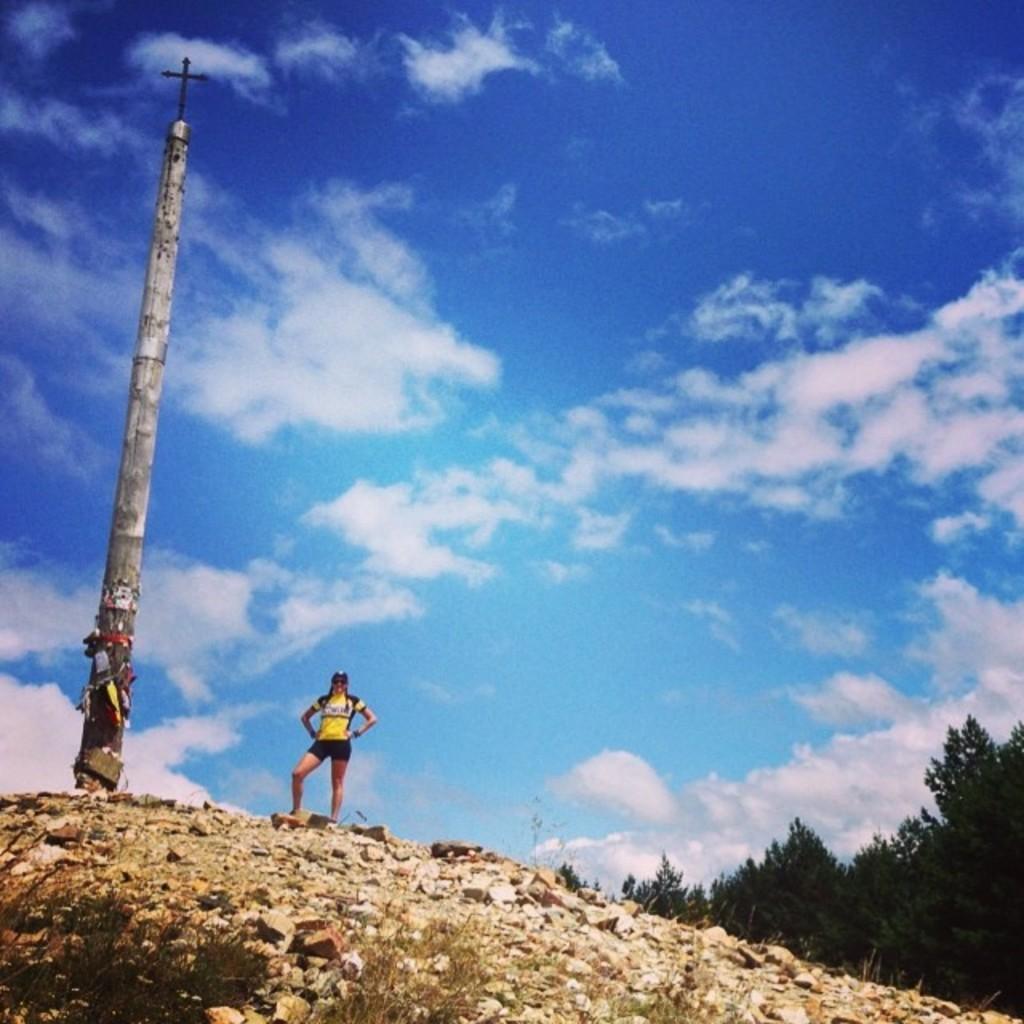How would you summarize this image in a sentence or two? In the center of the image we can see a lady is standing. On the left side of the image we can see a pole. On the right side of the image we can see the trees. At the bottom of the image we can see the plants and stones. In the background of the image we can see the clouds are present in the sky. 